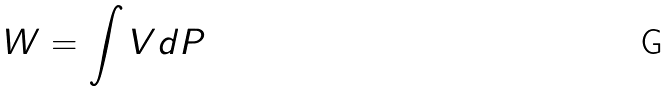Convert formula to latex. <formula><loc_0><loc_0><loc_500><loc_500>W = \int V d P</formula> 